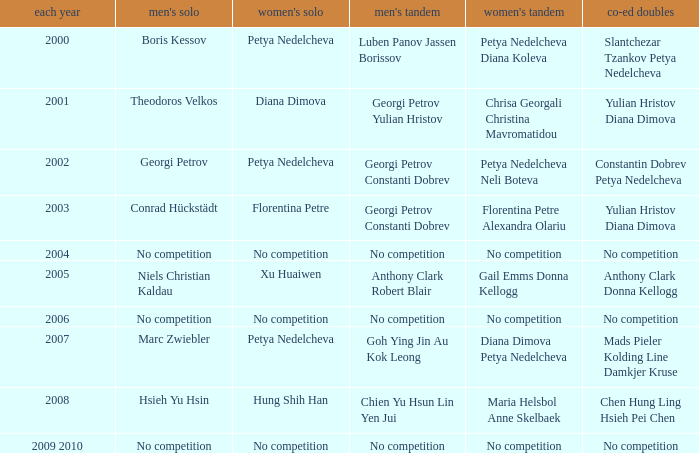What is the year when Conrad Hückstädt won Men's Single? 2003.0. 